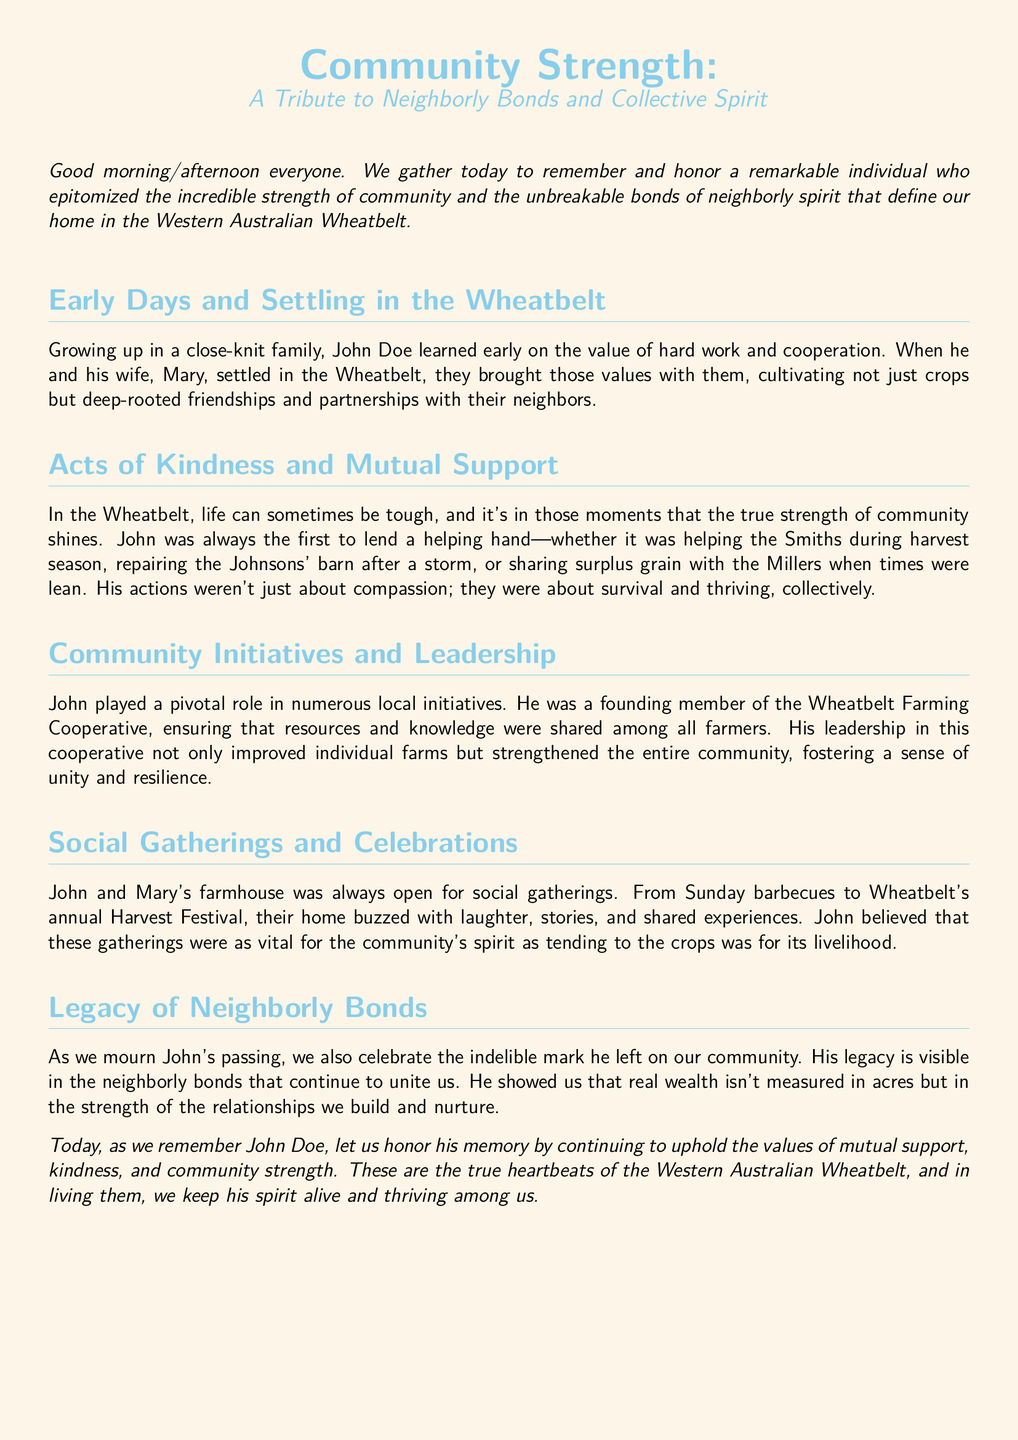What was John's full name? The document mentions John Doe as the individual being honored in the eulogy.
Answer: John Doe Who was John's wife? The eulogy states that John's wife was named Mary.
Answer: Mary What cooperative did John help found? The text refers to the Wheatbelt Farming Cooperative as a local initiative he was involved in.
Answer: Wheatbelt Farming Cooperative What types of gatherings did John and Mary host? The eulogy describes social gatherings at their farmhouse, specifically mentioning Sunday barbecues and the annual Harvest Festival.
Answer: Sunday barbecues and Harvest Festival What was a key theme of John's legacy? The eulogy emphasizes the importance of neighborly bonds and relationships in the community as John's legacy.
Answer: Neighborly bonds How did John contribute during tough times? According to the eulogy, John helped neighbors during tough times by lending a helping hand and sharing resources.
Answer: Helping hand and sharing resources What did John believe was vital for the community's spirit? The document highlights that John considered social gatherings vital for the community's spirit.
Answer: Social gatherings What is described as 'real wealth' in the eulogy? The text indicates that real wealth is measured in the strength of relationships built within the community.
Answer: Strength of relationships 